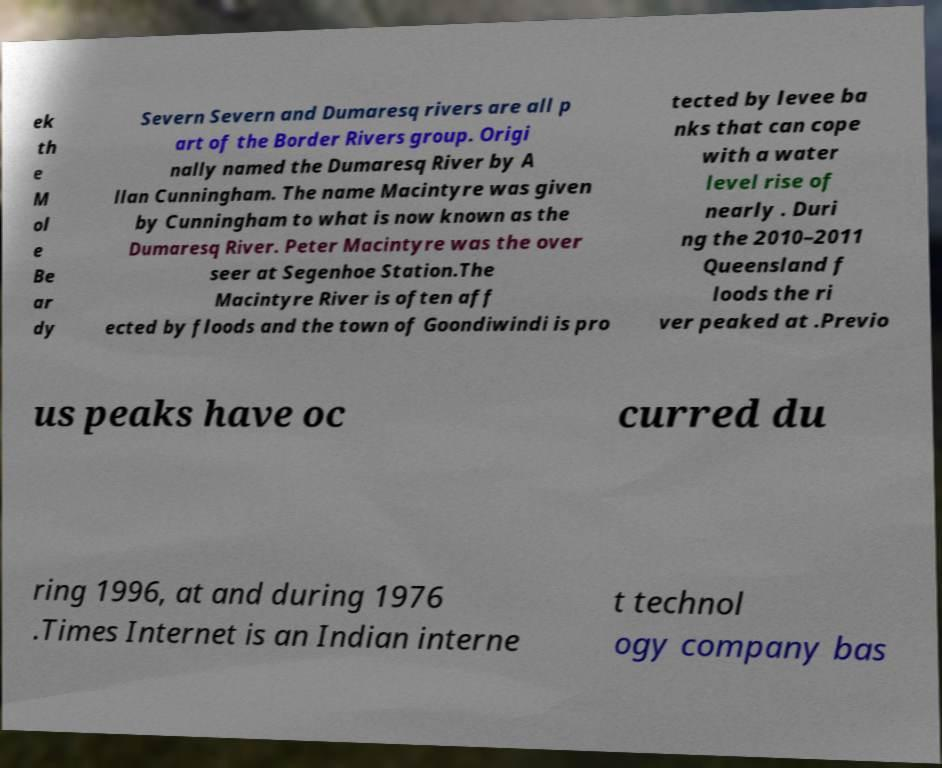Can you accurately transcribe the text from the provided image for me? ek th e M ol e Be ar dy Severn Severn and Dumaresq rivers are all p art of the Border Rivers group. Origi nally named the Dumaresq River by A llan Cunningham. The name Macintyre was given by Cunningham to what is now known as the Dumaresq River. Peter Macintyre was the over seer at Segenhoe Station.The Macintyre River is often aff ected by floods and the town of Goondiwindi is pro tected by levee ba nks that can cope with a water level rise of nearly . Duri ng the 2010–2011 Queensland f loods the ri ver peaked at .Previo us peaks have oc curred du ring 1996, at and during 1976 .Times Internet is an Indian interne t technol ogy company bas 